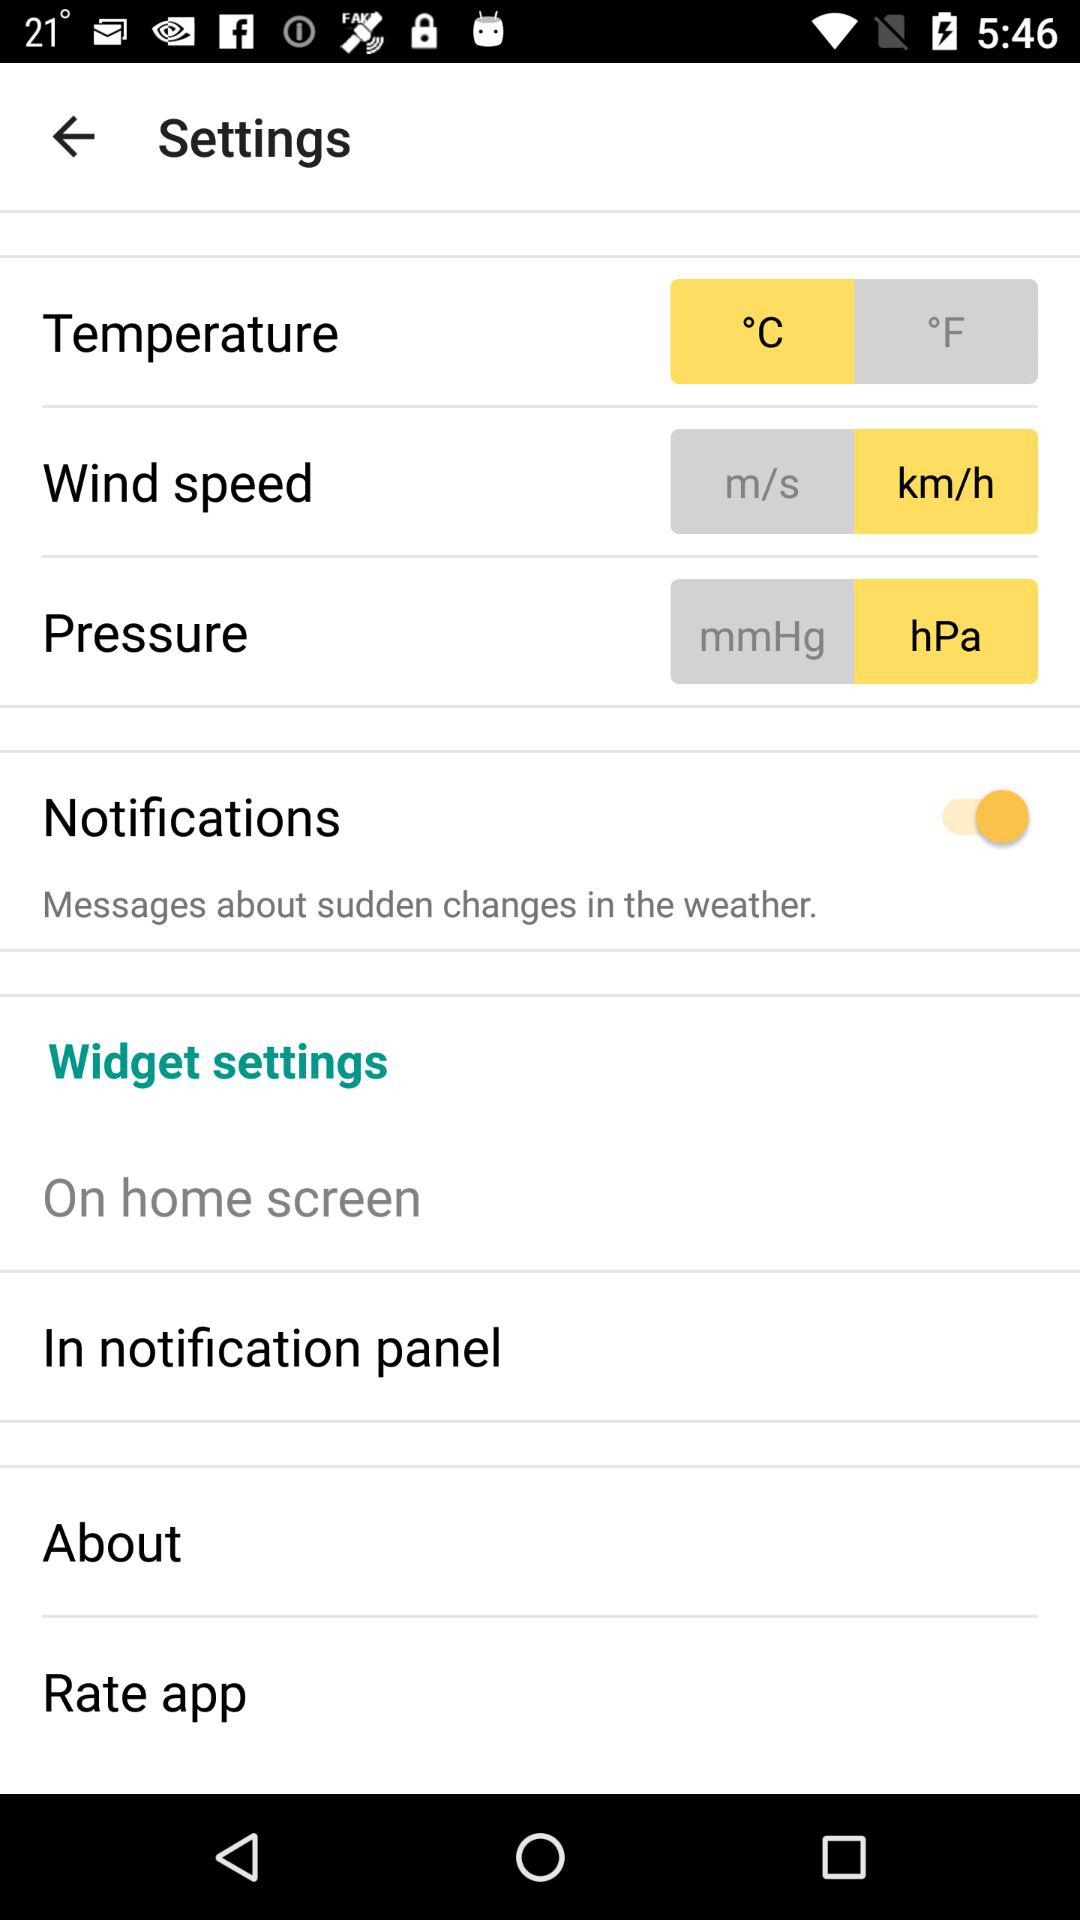What is the status of "Notifications"? The status of "Notifications" is "on". 